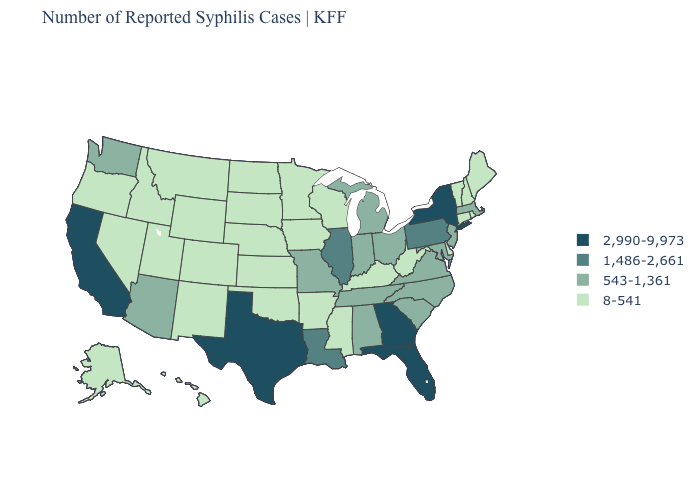What is the value of Alaska?
Keep it brief. 8-541. What is the value of Illinois?
Concise answer only. 1,486-2,661. Name the states that have a value in the range 8-541?
Give a very brief answer. Alaska, Arkansas, Colorado, Connecticut, Delaware, Hawaii, Idaho, Iowa, Kansas, Kentucky, Maine, Minnesota, Mississippi, Montana, Nebraska, Nevada, New Hampshire, New Mexico, North Dakota, Oklahoma, Oregon, Rhode Island, South Dakota, Utah, Vermont, West Virginia, Wisconsin, Wyoming. Among the states that border Louisiana , does Arkansas have the lowest value?
Quick response, please. Yes. What is the lowest value in states that border Minnesota?
Short answer required. 8-541. What is the lowest value in states that border Missouri?
Answer briefly. 8-541. Among the states that border Delaware , which have the lowest value?
Keep it brief. Maryland, New Jersey. What is the value of Maryland?
Short answer required. 543-1,361. Is the legend a continuous bar?
Short answer required. No. Name the states that have a value in the range 1,486-2,661?
Write a very short answer. Illinois, Louisiana, Pennsylvania. What is the highest value in the USA?
Short answer required. 2,990-9,973. Does West Virginia have the same value as Idaho?
Answer briefly. Yes. Does Massachusetts have a lower value than Wyoming?
Concise answer only. No. Which states have the lowest value in the MidWest?
Write a very short answer. Iowa, Kansas, Minnesota, Nebraska, North Dakota, South Dakota, Wisconsin. What is the lowest value in the USA?
Short answer required. 8-541. 